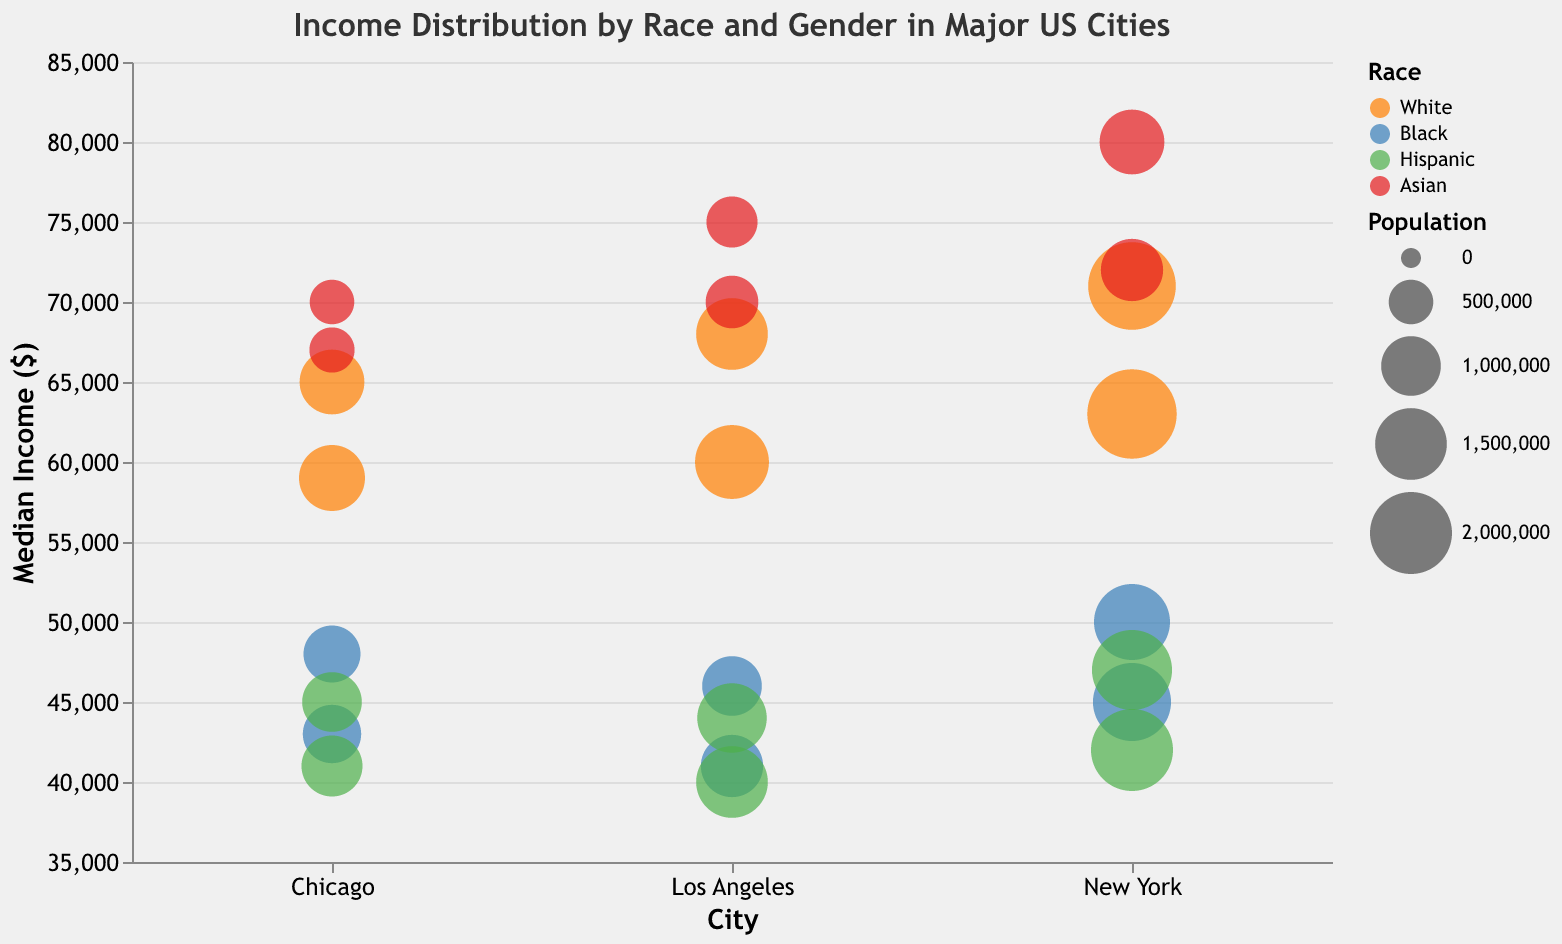What's the title of the bubble chart? To find the title, you look at the top portion of the chart. The title is often a short phrase summarizing the main topic or the data provided in the chart.
Answer: Income Distribution by Race and Gender in Major US Cities How many cities are represented in the chart? To determine the number of cities, you examine the x-axis labels, as each city should have its unique label. Here, the x-axis shows New York, Los Angeles, and Chicago, which are three labels corresponding to cities.
Answer: 3 Which gender generally has higher median incomes among Asian people in these cities? To answer this, you look at the shapes of the points colored for Asian people (red) and compare the heights between circles and triangles. In all three cities, male (circle) points are higher than female (triangle) points.
Answer: Male In which city do Hispanic females have the lowest median income? To determine this, identify the triangular points colored for Hispanic people (green) in each city and compare their heights. In Los Angeles, the Hispanic female point is the lowest among the cities.
Answer: Los Angeles What is the size difference between the Black male population in New York and Los Angeles? To find this, look at the circle points colored for Black people (blue) representing males, then compare their relative sizes. The population for Black males in New York is represented with a larger circle than that in Los Angeles. • Calculate the numerical difference: 1,700,000 - 1,000,000
Answer: 700,000 What is the median income of Asian females in Chicago? Identify the triangular red point in the Chicago section and look at its y-axis value. The point's height corresponds to 67,000 on the y-axis, indicating the median income.
Answer: 67,000 Which city has the highest overall median income for White males? For this, look at the circle points representing White males (orange) and identify the highest point among the cities. New York's White male point is higher than Los Angeles and Chicago.
Answer: New York Compare the median income of White females and Black females in New York. What is the difference? Identify the corresponding triangular points in the New York City section: White females (orange) and Black females (blue). The White female point is at 63,000 and the Black female point is at 45,000. Calculate the difference: 63,000 - 45,000
Answer: 18,000 What is the population of Hispanic females in New York compared to Chicago? Compare the sizes of the triangular green points in New York and Chicago. The population size in New York is 2,000,000 and in Chicago is 1,050,000.
Answer: 950,000 Which demographic group has the lowest median income in Los Angeles? To determine this, identify the lowest point in the Los Angeles section and examine its color and shape. The lowest point's color is green, and its shape is a triangle, indicating Hispanic females.
Answer: Hispanic females 